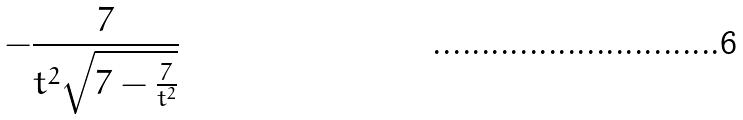Convert formula to latex. <formula><loc_0><loc_0><loc_500><loc_500>- \frac { 7 } { t ^ { 2 } \sqrt { 7 - \frac { 7 } { t ^ { 2 } } } }</formula> 